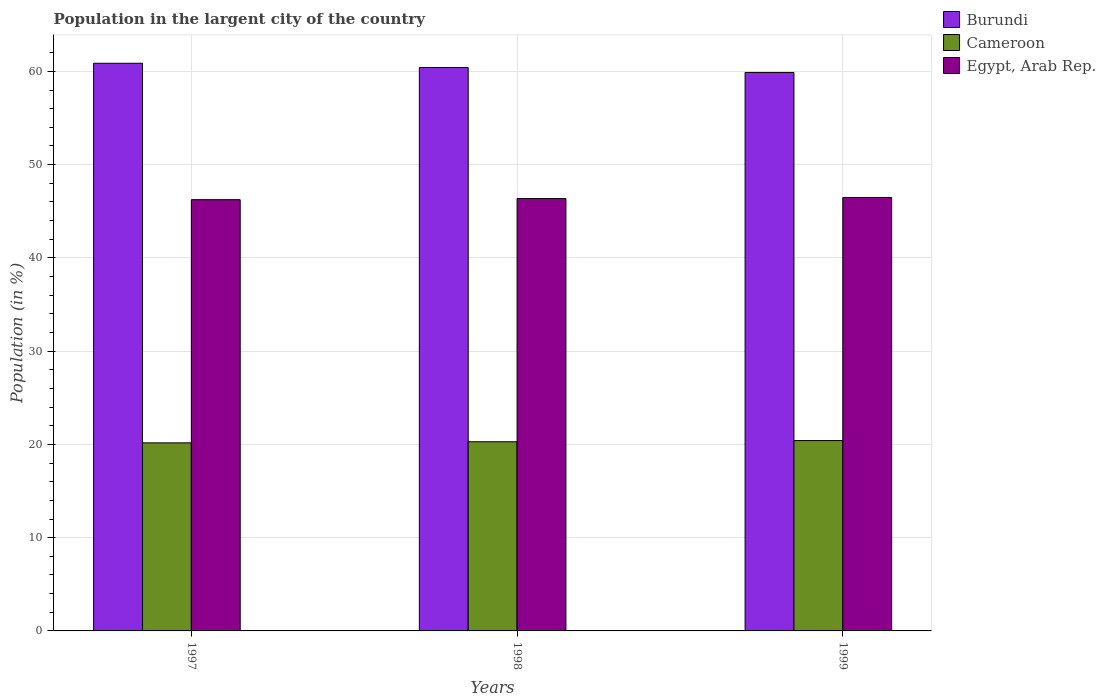How many different coloured bars are there?
Provide a succinct answer. 3. How many groups of bars are there?
Offer a very short reply. 3. Are the number of bars per tick equal to the number of legend labels?
Make the answer very short. Yes. Are the number of bars on each tick of the X-axis equal?
Offer a very short reply. Yes. How many bars are there on the 3rd tick from the left?
Provide a short and direct response. 3. How many bars are there on the 1st tick from the right?
Your answer should be compact. 3. In how many cases, is the number of bars for a given year not equal to the number of legend labels?
Provide a short and direct response. 0. What is the percentage of population in the largent city in Burundi in 1998?
Ensure brevity in your answer.  60.42. Across all years, what is the maximum percentage of population in the largent city in Burundi?
Your answer should be very brief. 60.87. Across all years, what is the minimum percentage of population in the largent city in Burundi?
Provide a succinct answer. 59.88. In which year was the percentage of population in the largent city in Burundi maximum?
Keep it short and to the point. 1997. What is the total percentage of population in the largent city in Cameroon in the graph?
Ensure brevity in your answer.  60.86. What is the difference between the percentage of population in the largent city in Cameroon in 1997 and that in 1998?
Make the answer very short. -0.12. What is the difference between the percentage of population in the largent city in Egypt, Arab Rep. in 1997 and the percentage of population in the largent city in Cameroon in 1998?
Your answer should be very brief. 25.96. What is the average percentage of population in the largent city in Burundi per year?
Provide a succinct answer. 60.39. In the year 1998, what is the difference between the percentage of population in the largent city in Cameroon and percentage of population in the largent city in Burundi?
Your response must be concise. -40.13. What is the ratio of the percentage of population in the largent city in Burundi in 1997 to that in 1998?
Offer a very short reply. 1.01. Is the percentage of population in the largent city in Egypt, Arab Rep. in 1998 less than that in 1999?
Your response must be concise. Yes. Is the difference between the percentage of population in the largent city in Cameroon in 1997 and 1998 greater than the difference between the percentage of population in the largent city in Burundi in 1997 and 1998?
Your response must be concise. No. What is the difference between the highest and the second highest percentage of population in the largent city in Egypt, Arab Rep.?
Your answer should be compact. 0.12. What is the difference between the highest and the lowest percentage of population in the largent city in Egypt, Arab Rep.?
Offer a very short reply. 0.24. In how many years, is the percentage of population in the largent city in Egypt, Arab Rep. greater than the average percentage of population in the largent city in Egypt, Arab Rep. taken over all years?
Provide a succinct answer. 2. Is the sum of the percentage of population in the largent city in Burundi in 1997 and 1999 greater than the maximum percentage of population in the largent city in Egypt, Arab Rep. across all years?
Offer a terse response. Yes. What does the 2nd bar from the left in 1998 represents?
Your response must be concise. Cameroon. What does the 1st bar from the right in 1997 represents?
Make the answer very short. Egypt, Arab Rep. Are all the bars in the graph horizontal?
Your answer should be compact. No. Are the values on the major ticks of Y-axis written in scientific E-notation?
Offer a terse response. No. Does the graph contain any zero values?
Your answer should be very brief. No. Does the graph contain grids?
Ensure brevity in your answer.  Yes. Where does the legend appear in the graph?
Ensure brevity in your answer.  Top right. How many legend labels are there?
Provide a short and direct response. 3. How are the legend labels stacked?
Give a very brief answer. Vertical. What is the title of the graph?
Give a very brief answer. Population in the largent city of the country. What is the label or title of the X-axis?
Give a very brief answer. Years. What is the Population (in %) in Burundi in 1997?
Provide a short and direct response. 60.87. What is the Population (in %) of Cameroon in 1997?
Offer a terse response. 20.17. What is the Population (in %) of Egypt, Arab Rep. in 1997?
Your answer should be very brief. 46.24. What is the Population (in %) in Burundi in 1998?
Keep it short and to the point. 60.42. What is the Population (in %) in Cameroon in 1998?
Your response must be concise. 20.28. What is the Population (in %) in Egypt, Arab Rep. in 1998?
Your answer should be very brief. 46.36. What is the Population (in %) of Burundi in 1999?
Your answer should be compact. 59.88. What is the Population (in %) of Cameroon in 1999?
Ensure brevity in your answer.  20.41. What is the Population (in %) of Egypt, Arab Rep. in 1999?
Offer a terse response. 46.48. Across all years, what is the maximum Population (in %) in Burundi?
Your answer should be very brief. 60.87. Across all years, what is the maximum Population (in %) in Cameroon?
Your answer should be compact. 20.41. Across all years, what is the maximum Population (in %) of Egypt, Arab Rep.?
Your response must be concise. 46.48. Across all years, what is the minimum Population (in %) in Burundi?
Provide a succinct answer. 59.88. Across all years, what is the minimum Population (in %) of Cameroon?
Ensure brevity in your answer.  20.17. Across all years, what is the minimum Population (in %) in Egypt, Arab Rep.?
Provide a succinct answer. 46.24. What is the total Population (in %) in Burundi in the graph?
Your answer should be compact. 181.17. What is the total Population (in %) of Cameroon in the graph?
Your response must be concise. 60.86. What is the total Population (in %) of Egypt, Arab Rep. in the graph?
Make the answer very short. 139.08. What is the difference between the Population (in %) in Burundi in 1997 and that in 1998?
Your answer should be compact. 0.45. What is the difference between the Population (in %) of Cameroon in 1997 and that in 1998?
Your response must be concise. -0.12. What is the difference between the Population (in %) of Egypt, Arab Rep. in 1997 and that in 1998?
Your answer should be very brief. -0.12. What is the difference between the Population (in %) in Burundi in 1997 and that in 1999?
Provide a succinct answer. 0.99. What is the difference between the Population (in %) in Cameroon in 1997 and that in 1999?
Provide a succinct answer. -0.24. What is the difference between the Population (in %) in Egypt, Arab Rep. in 1997 and that in 1999?
Make the answer very short. -0.24. What is the difference between the Population (in %) of Burundi in 1998 and that in 1999?
Keep it short and to the point. 0.53. What is the difference between the Population (in %) of Cameroon in 1998 and that in 1999?
Your answer should be compact. -0.13. What is the difference between the Population (in %) of Egypt, Arab Rep. in 1998 and that in 1999?
Your response must be concise. -0.12. What is the difference between the Population (in %) of Burundi in 1997 and the Population (in %) of Cameroon in 1998?
Make the answer very short. 40.58. What is the difference between the Population (in %) of Burundi in 1997 and the Population (in %) of Egypt, Arab Rep. in 1998?
Offer a terse response. 14.51. What is the difference between the Population (in %) of Cameroon in 1997 and the Population (in %) of Egypt, Arab Rep. in 1998?
Provide a short and direct response. -26.19. What is the difference between the Population (in %) of Burundi in 1997 and the Population (in %) of Cameroon in 1999?
Your answer should be compact. 40.46. What is the difference between the Population (in %) in Burundi in 1997 and the Population (in %) in Egypt, Arab Rep. in 1999?
Ensure brevity in your answer.  14.39. What is the difference between the Population (in %) of Cameroon in 1997 and the Population (in %) of Egypt, Arab Rep. in 1999?
Offer a very short reply. -26.31. What is the difference between the Population (in %) of Burundi in 1998 and the Population (in %) of Cameroon in 1999?
Make the answer very short. 40.01. What is the difference between the Population (in %) in Burundi in 1998 and the Population (in %) in Egypt, Arab Rep. in 1999?
Offer a terse response. 13.94. What is the difference between the Population (in %) in Cameroon in 1998 and the Population (in %) in Egypt, Arab Rep. in 1999?
Give a very brief answer. -26.19. What is the average Population (in %) in Burundi per year?
Provide a succinct answer. 60.39. What is the average Population (in %) in Cameroon per year?
Your response must be concise. 20.29. What is the average Population (in %) in Egypt, Arab Rep. per year?
Provide a short and direct response. 46.36. In the year 1997, what is the difference between the Population (in %) of Burundi and Population (in %) of Cameroon?
Provide a short and direct response. 40.7. In the year 1997, what is the difference between the Population (in %) of Burundi and Population (in %) of Egypt, Arab Rep.?
Offer a terse response. 14.63. In the year 1997, what is the difference between the Population (in %) in Cameroon and Population (in %) in Egypt, Arab Rep.?
Your response must be concise. -26.07. In the year 1998, what is the difference between the Population (in %) of Burundi and Population (in %) of Cameroon?
Keep it short and to the point. 40.13. In the year 1998, what is the difference between the Population (in %) in Burundi and Population (in %) in Egypt, Arab Rep.?
Give a very brief answer. 14.06. In the year 1998, what is the difference between the Population (in %) of Cameroon and Population (in %) of Egypt, Arab Rep.?
Your answer should be compact. -26.07. In the year 1999, what is the difference between the Population (in %) of Burundi and Population (in %) of Cameroon?
Offer a very short reply. 39.47. In the year 1999, what is the difference between the Population (in %) in Burundi and Population (in %) in Egypt, Arab Rep.?
Provide a succinct answer. 13.4. In the year 1999, what is the difference between the Population (in %) in Cameroon and Population (in %) in Egypt, Arab Rep.?
Give a very brief answer. -26.07. What is the ratio of the Population (in %) in Burundi in 1997 to that in 1998?
Provide a short and direct response. 1.01. What is the ratio of the Population (in %) in Cameroon in 1997 to that in 1998?
Keep it short and to the point. 0.99. What is the ratio of the Population (in %) in Burundi in 1997 to that in 1999?
Your answer should be compact. 1.02. What is the ratio of the Population (in %) of Cameroon in 1997 to that in 1999?
Your answer should be very brief. 0.99. What is the ratio of the Population (in %) in Burundi in 1998 to that in 1999?
Give a very brief answer. 1.01. What is the ratio of the Population (in %) in Egypt, Arab Rep. in 1998 to that in 1999?
Ensure brevity in your answer.  1. What is the difference between the highest and the second highest Population (in %) of Burundi?
Ensure brevity in your answer.  0.45. What is the difference between the highest and the second highest Population (in %) of Cameroon?
Your answer should be compact. 0.13. What is the difference between the highest and the second highest Population (in %) of Egypt, Arab Rep.?
Ensure brevity in your answer.  0.12. What is the difference between the highest and the lowest Population (in %) in Burundi?
Make the answer very short. 0.99. What is the difference between the highest and the lowest Population (in %) in Cameroon?
Offer a very short reply. 0.24. What is the difference between the highest and the lowest Population (in %) in Egypt, Arab Rep.?
Your answer should be very brief. 0.24. 